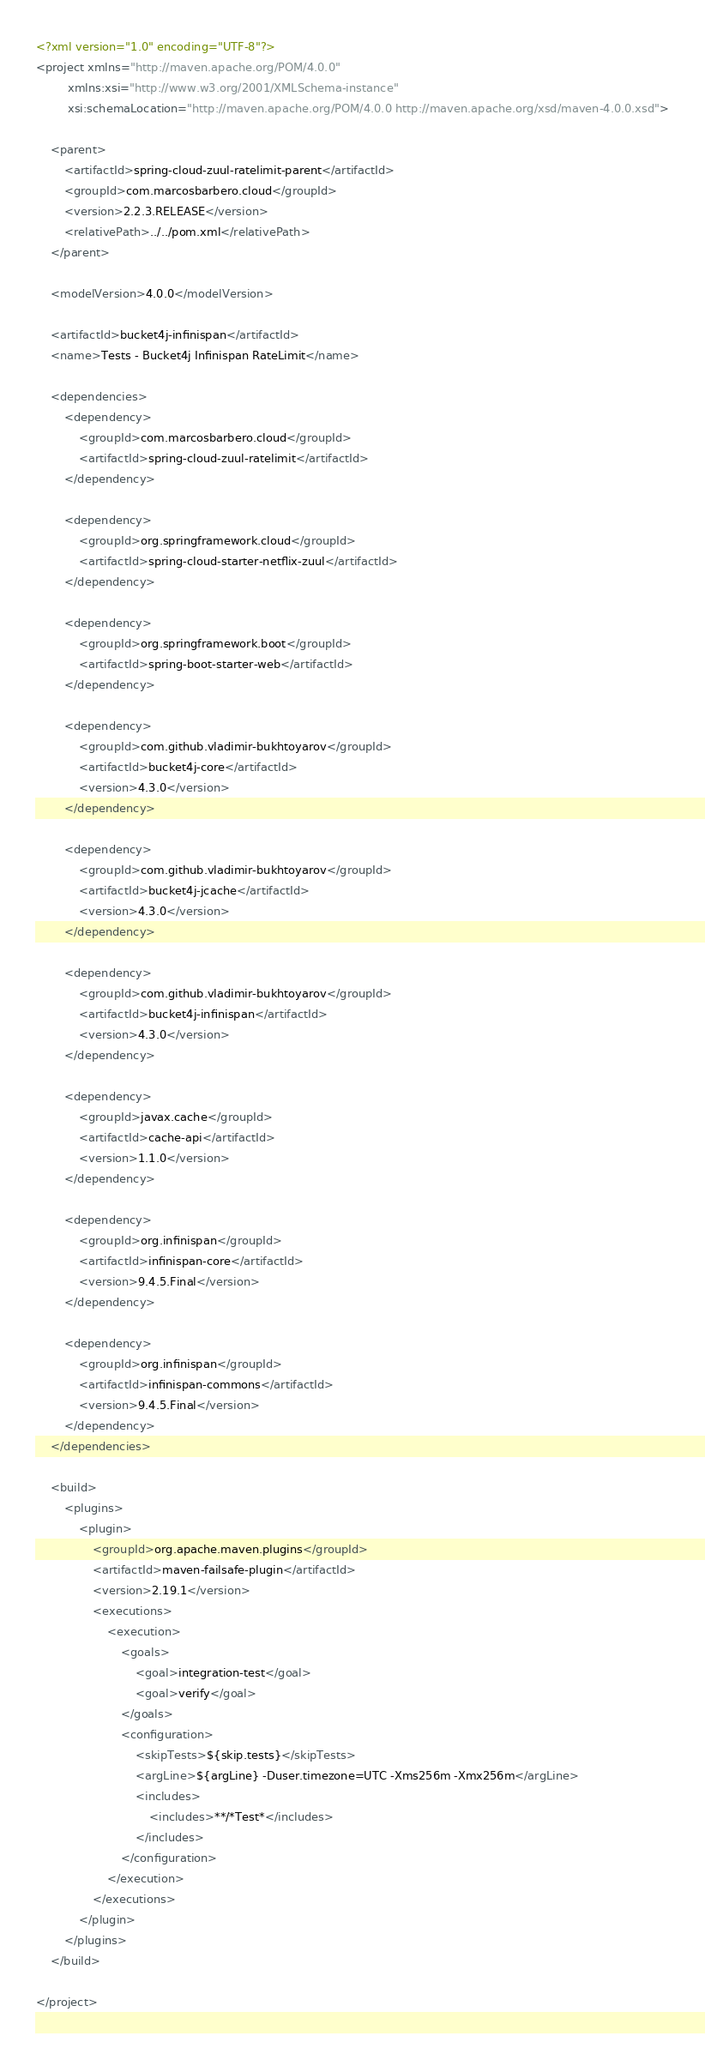<code> <loc_0><loc_0><loc_500><loc_500><_XML_><?xml version="1.0" encoding="UTF-8"?>
<project xmlns="http://maven.apache.org/POM/4.0.0"
         xmlns:xsi="http://www.w3.org/2001/XMLSchema-instance"
         xsi:schemaLocation="http://maven.apache.org/POM/4.0.0 http://maven.apache.org/xsd/maven-4.0.0.xsd">

    <parent>
        <artifactId>spring-cloud-zuul-ratelimit-parent</artifactId>
        <groupId>com.marcosbarbero.cloud</groupId>
        <version>2.2.3.RELEASE</version>
        <relativePath>../../pom.xml</relativePath>
    </parent>

    <modelVersion>4.0.0</modelVersion>

    <artifactId>bucket4j-infinispan</artifactId>
    <name>Tests - Bucket4j Infinispan RateLimit</name>

    <dependencies>
        <dependency>
            <groupId>com.marcosbarbero.cloud</groupId>
            <artifactId>spring-cloud-zuul-ratelimit</artifactId>
        </dependency>

        <dependency>
            <groupId>org.springframework.cloud</groupId>
            <artifactId>spring-cloud-starter-netflix-zuul</artifactId>
        </dependency>

        <dependency>
            <groupId>org.springframework.boot</groupId>
            <artifactId>spring-boot-starter-web</artifactId>
        </dependency>

        <dependency>
            <groupId>com.github.vladimir-bukhtoyarov</groupId>
            <artifactId>bucket4j-core</artifactId>
            <version>4.3.0</version>
        </dependency>

        <dependency>
            <groupId>com.github.vladimir-bukhtoyarov</groupId>
            <artifactId>bucket4j-jcache</artifactId>
            <version>4.3.0</version>
        </dependency>

        <dependency>
            <groupId>com.github.vladimir-bukhtoyarov</groupId>
            <artifactId>bucket4j-infinispan</artifactId>
            <version>4.3.0</version>
        </dependency>

        <dependency>
            <groupId>javax.cache</groupId>
            <artifactId>cache-api</artifactId>
            <version>1.1.0</version>
        </dependency>

        <dependency>
            <groupId>org.infinispan</groupId>
            <artifactId>infinispan-core</artifactId>
            <version>9.4.5.Final</version>
        </dependency>

        <dependency>
            <groupId>org.infinispan</groupId>
            <artifactId>infinispan-commons</artifactId>
            <version>9.4.5.Final</version>
        </dependency>
    </dependencies>

    <build>
        <plugins>
            <plugin>
                <groupId>org.apache.maven.plugins</groupId>
                <artifactId>maven-failsafe-plugin</artifactId>
                <version>2.19.1</version>
                <executions>
                    <execution>
                        <goals>
                            <goal>integration-test</goal>
                            <goal>verify</goal>
                        </goals>
                        <configuration>
                            <skipTests>${skip.tests}</skipTests>
                            <argLine>${argLine} -Duser.timezone=UTC -Xms256m -Xmx256m</argLine>
                            <includes>
                                <includes>**/*Test*</includes>
                            </includes>
                        </configuration>
                    </execution>
                </executions>
            </plugin>
        </plugins>
    </build>

</project></code> 